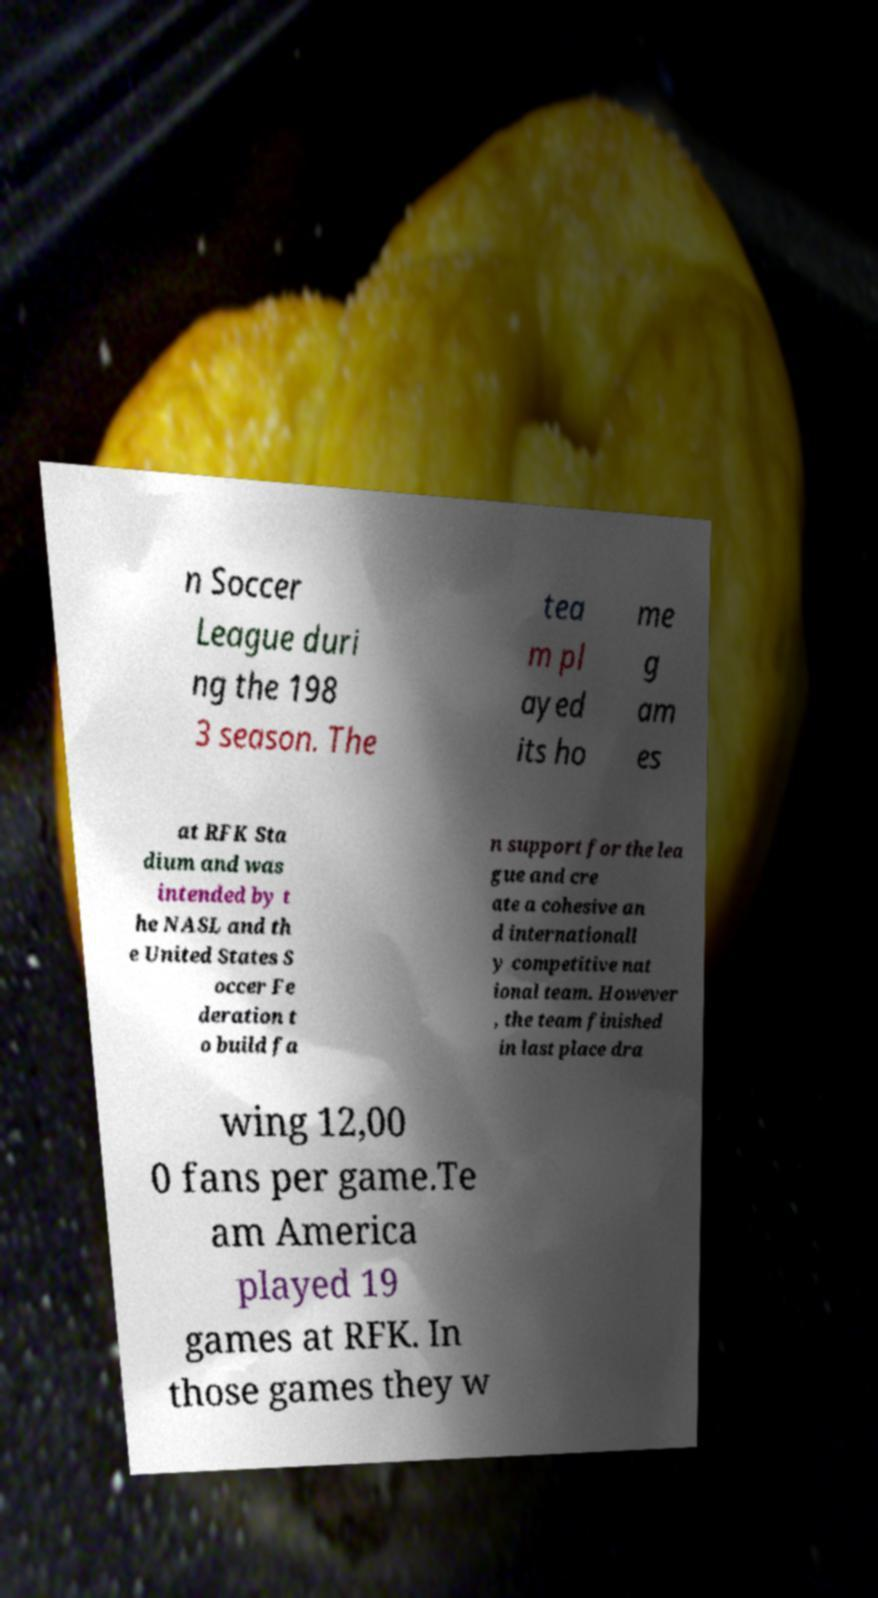For documentation purposes, I need the text within this image transcribed. Could you provide that? n Soccer League duri ng the 198 3 season. The tea m pl ayed its ho me g am es at RFK Sta dium and was intended by t he NASL and th e United States S occer Fe deration t o build fa n support for the lea gue and cre ate a cohesive an d internationall y competitive nat ional team. However , the team finished in last place dra wing 12,00 0 fans per game.Te am America played 19 games at RFK. In those games they w 